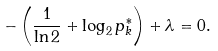Convert formula to latex. <formula><loc_0><loc_0><loc_500><loc_500>- \left ( { \frac { 1 } { \ln 2 } } + \log _ { 2 } p _ { k } ^ { * } \right ) + \lambda = 0 .</formula> 